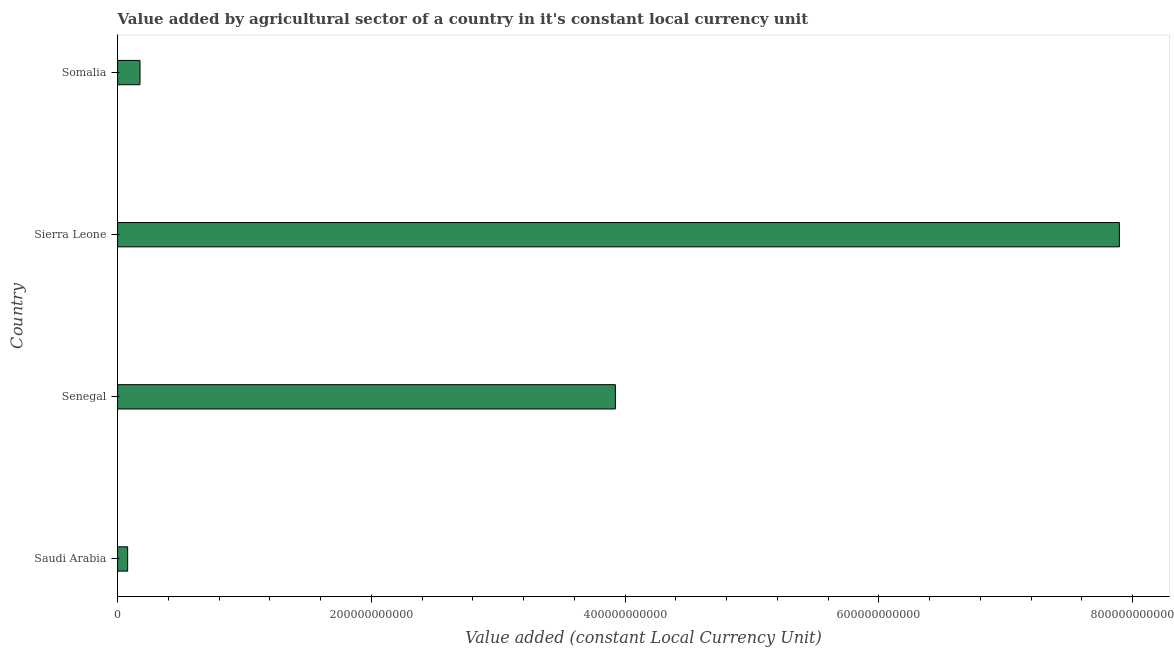What is the title of the graph?
Provide a short and direct response. Value added by agricultural sector of a country in it's constant local currency unit. What is the label or title of the X-axis?
Keep it short and to the point. Value added (constant Local Currency Unit). What is the label or title of the Y-axis?
Offer a very short reply. Country. What is the value added by agriculture sector in Sierra Leone?
Keep it short and to the point. 7.90e+11. Across all countries, what is the maximum value added by agriculture sector?
Offer a very short reply. 7.90e+11. Across all countries, what is the minimum value added by agriculture sector?
Make the answer very short. 7.91e+09. In which country was the value added by agriculture sector maximum?
Keep it short and to the point. Sierra Leone. In which country was the value added by agriculture sector minimum?
Your answer should be compact. Saudi Arabia. What is the sum of the value added by agriculture sector?
Ensure brevity in your answer.  1.21e+12. What is the difference between the value added by agriculture sector in Saudi Arabia and Sierra Leone?
Offer a terse response. -7.82e+11. What is the average value added by agriculture sector per country?
Your response must be concise. 3.02e+11. What is the median value added by agriculture sector?
Make the answer very short. 2.05e+11. What is the ratio of the value added by agriculture sector in Sierra Leone to that in Somalia?
Offer a terse response. 44.74. Is the difference between the value added by agriculture sector in Saudi Arabia and Somalia greater than the difference between any two countries?
Your answer should be very brief. No. What is the difference between the highest and the second highest value added by agriculture sector?
Provide a short and direct response. 3.97e+11. Is the sum of the value added by agriculture sector in Saudi Arabia and Sierra Leone greater than the maximum value added by agriculture sector across all countries?
Offer a very short reply. Yes. What is the difference between the highest and the lowest value added by agriculture sector?
Give a very brief answer. 7.82e+11. In how many countries, is the value added by agriculture sector greater than the average value added by agriculture sector taken over all countries?
Your answer should be compact. 2. Are all the bars in the graph horizontal?
Your response must be concise. Yes. What is the difference between two consecutive major ticks on the X-axis?
Offer a terse response. 2.00e+11. Are the values on the major ticks of X-axis written in scientific E-notation?
Make the answer very short. No. What is the Value added (constant Local Currency Unit) in Saudi Arabia?
Offer a terse response. 7.91e+09. What is the Value added (constant Local Currency Unit) of Senegal?
Offer a very short reply. 3.92e+11. What is the Value added (constant Local Currency Unit) in Sierra Leone?
Your response must be concise. 7.90e+11. What is the Value added (constant Local Currency Unit) in Somalia?
Offer a very short reply. 1.76e+1. What is the difference between the Value added (constant Local Currency Unit) in Saudi Arabia and Senegal?
Your answer should be very brief. -3.84e+11. What is the difference between the Value added (constant Local Currency Unit) in Saudi Arabia and Sierra Leone?
Keep it short and to the point. -7.82e+11. What is the difference between the Value added (constant Local Currency Unit) in Saudi Arabia and Somalia?
Provide a short and direct response. -9.74e+09. What is the difference between the Value added (constant Local Currency Unit) in Senegal and Sierra Leone?
Keep it short and to the point. -3.97e+11. What is the difference between the Value added (constant Local Currency Unit) in Senegal and Somalia?
Keep it short and to the point. 3.75e+11. What is the difference between the Value added (constant Local Currency Unit) in Sierra Leone and Somalia?
Offer a very short reply. 7.72e+11. What is the ratio of the Value added (constant Local Currency Unit) in Saudi Arabia to that in Senegal?
Keep it short and to the point. 0.02. What is the ratio of the Value added (constant Local Currency Unit) in Saudi Arabia to that in Somalia?
Your answer should be compact. 0.45. What is the ratio of the Value added (constant Local Currency Unit) in Senegal to that in Sierra Leone?
Provide a short and direct response. 0.5. What is the ratio of the Value added (constant Local Currency Unit) in Senegal to that in Somalia?
Ensure brevity in your answer.  22.23. What is the ratio of the Value added (constant Local Currency Unit) in Sierra Leone to that in Somalia?
Make the answer very short. 44.74. 